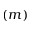Convert formula to latex. <formula><loc_0><loc_0><loc_500><loc_500>( m )</formula> 